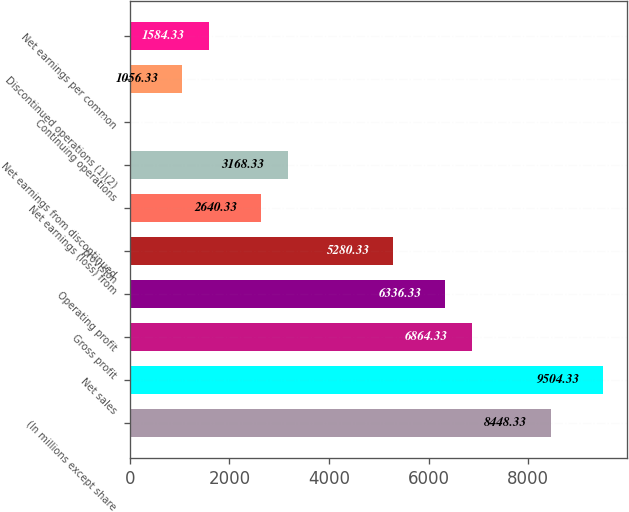Convert chart to OTSL. <chart><loc_0><loc_0><loc_500><loc_500><bar_chart><fcel>(In millions except share<fcel>Net sales<fcel>Gross profit<fcel>Operating profit<fcel>provision<fcel>Net earnings (loss) from<fcel>Net earnings from discontinued<fcel>Continuing operations<fcel>Discontinued operations (1)(2)<fcel>Net earnings per common<nl><fcel>8448.33<fcel>9504.33<fcel>6864.33<fcel>6336.33<fcel>5280.33<fcel>2640.33<fcel>3168.33<fcel>0.33<fcel>1056.33<fcel>1584.33<nl></chart> 